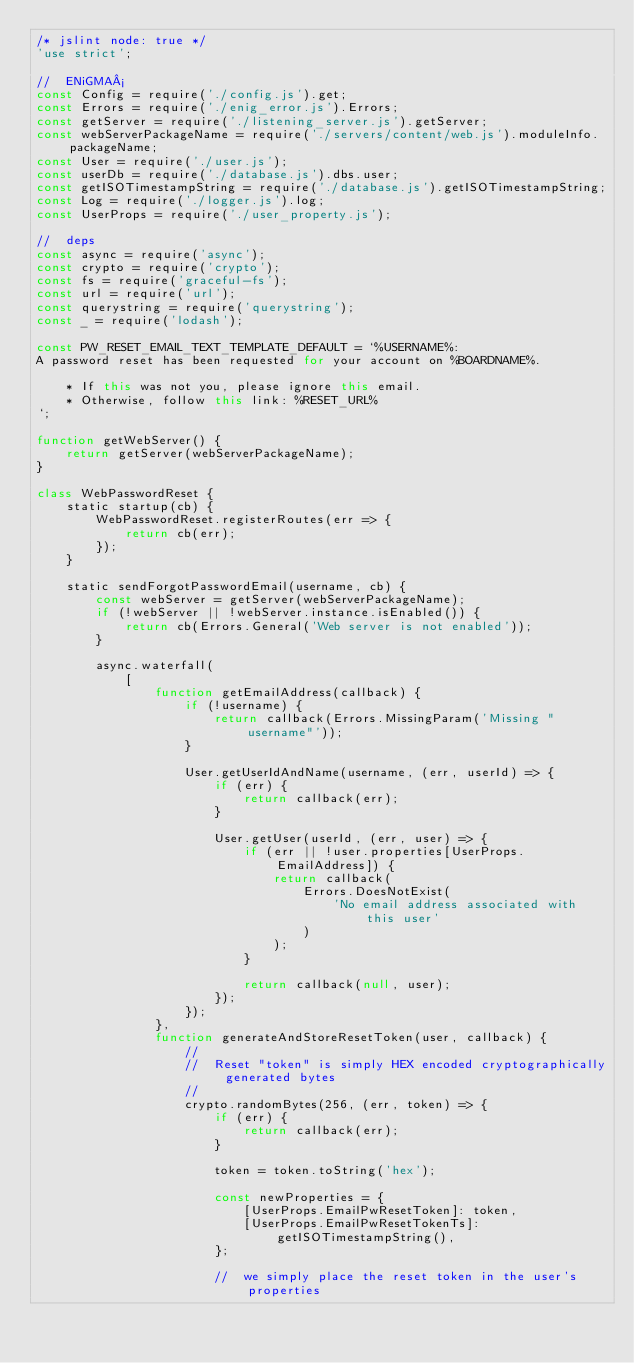<code> <loc_0><loc_0><loc_500><loc_500><_JavaScript_>/* jslint node: true */
'use strict';

//  ENiGMA½
const Config = require('./config.js').get;
const Errors = require('./enig_error.js').Errors;
const getServer = require('./listening_server.js').getServer;
const webServerPackageName = require('./servers/content/web.js').moduleInfo.packageName;
const User = require('./user.js');
const userDb = require('./database.js').dbs.user;
const getISOTimestampString = require('./database.js').getISOTimestampString;
const Log = require('./logger.js').log;
const UserProps = require('./user_property.js');

//  deps
const async = require('async');
const crypto = require('crypto');
const fs = require('graceful-fs');
const url = require('url');
const querystring = require('querystring');
const _ = require('lodash');

const PW_RESET_EMAIL_TEXT_TEMPLATE_DEFAULT = `%USERNAME%:
A password reset has been requested for your account on %BOARDNAME%.
    
    * If this was not you, please ignore this email.
    * Otherwise, follow this link: %RESET_URL%
`;

function getWebServer() {
    return getServer(webServerPackageName);
}

class WebPasswordReset {
    static startup(cb) {
        WebPasswordReset.registerRoutes(err => {
            return cb(err);
        });
    }

    static sendForgotPasswordEmail(username, cb) {
        const webServer = getServer(webServerPackageName);
        if (!webServer || !webServer.instance.isEnabled()) {
            return cb(Errors.General('Web server is not enabled'));
        }

        async.waterfall(
            [
                function getEmailAddress(callback) {
                    if (!username) {
                        return callback(Errors.MissingParam('Missing "username"'));
                    }

                    User.getUserIdAndName(username, (err, userId) => {
                        if (err) {
                            return callback(err);
                        }

                        User.getUser(userId, (err, user) => {
                            if (err || !user.properties[UserProps.EmailAddress]) {
                                return callback(
                                    Errors.DoesNotExist(
                                        'No email address associated with this user'
                                    )
                                );
                            }

                            return callback(null, user);
                        });
                    });
                },
                function generateAndStoreResetToken(user, callback) {
                    //
                    //  Reset "token" is simply HEX encoded cryptographically generated bytes
                    //
                    crypto.randomBytes(256, (err, token) => {
                        if (err) {
                            return callback(err);
                        }

                        token = token.toString('hex');

                        const newProperties = {
                            [UserProps.EmailPwResetToken]: token,
                            [UserProps.EmailPwResetTokenTs]: getISOTimestampString(),
                        };

                        //  we simply place the reset token in the user's properties</code> 